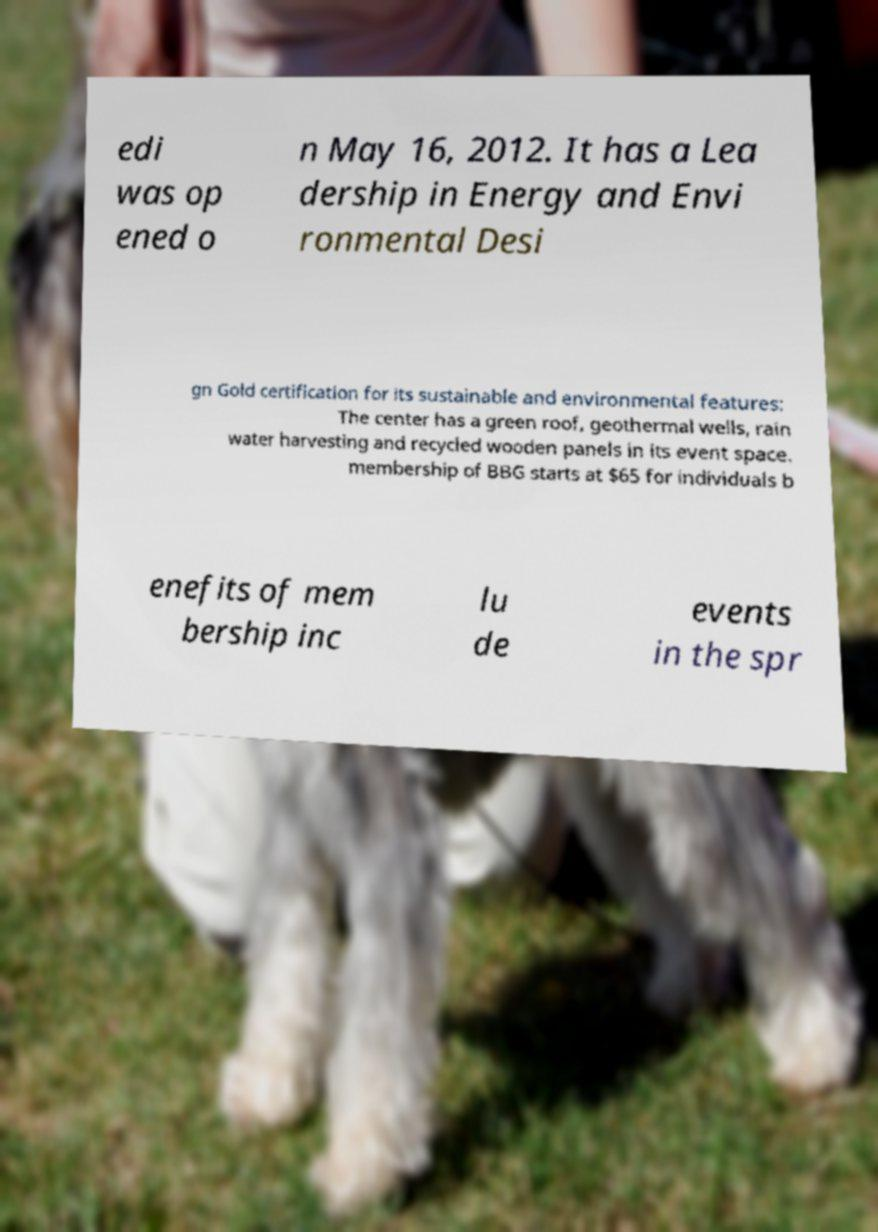For documentation purposes, I need the text within this image transcribed. Could you provide that? edi was op ened o n May 16, 2012. It has a Lea dership in Energy and Envi ronmental Desi gn Gold certification for its sustainable and environmental features: The center has a green roof, geothermal wells, rain water harvesting and recycled wooden panels in its event space. membership of BBG starts at $65 for individuals b enefits of mem bership inc lu de events in the spr 